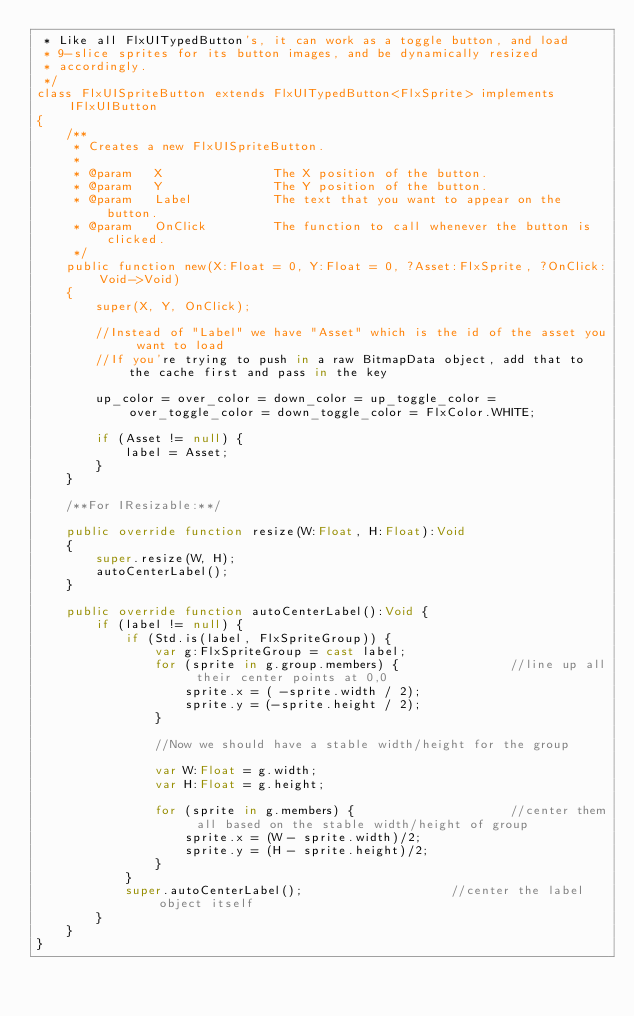Convert code to text. <code><loc_0><loc_0><loc_500><loc_500><_Haxe_> * Like all FlxUITypedButton's, it can work as a toggle button, and load
 * 9-slice sprites for its button images, and be dynamically resized 
 * accordingly.
 */
class FlxUISpriteButton extends FlxUITypedButton<FlxSprite> implements IFlxUIButton
{	
	/**
	 * Creates a new FlxUISpriteButton.
	 * 
	 * @param	X				The X position of the button.
	 * @param	Y				The Y position of the button.
	 * @param	Label			The text that you want to appear on the button.
	 * @param	OnClick			The function to call whenever the button is clicked.
	 */
	public function new(X:Float = 0, Y:Float = 0, ?Asset:FlxSprite, ?OnClick:Void->Void) 
	{
		super(X, Y, OnClick);
		
		//Instead of "Label" we have "Asset" which is the id of the asset you want to load
		//If you're trying to push in a raw BitmapData object, add that to the cache first and pass in the key
		
		up_color = over_color = down_color = up_toggle_color = over_toggle_color = down_toggle_color = FlxColor.WHITE;	
		
		if (Asset != null) {
			label = Asset;
		}
	}
	
	/**For IResizable:**/
	
	public override function resize(W:Float, H:Float):Void 
	{
		super.resize(W, H);
		autoCenterLabel();
	}
	
	public override function autoCenterLabel():Void {
		if (label != null) {
			if (Std.is(label, FlxSpriteGroup)) {
				var g:FlxSpriteGroup = cast label;
				for (sprite in g.group.members) {				//line up all their center points at 0,0
					sprite.x = ( -sprite.width / 2);
					sprite.y = (-sprite.height / 2);
				}
				
				//Now we should have a stable width/height for the group
				
				var W:Float = g.width;
				var H:Float = g.height;
				
				for (sprite in g.members) {						//center them all based on the stable width/height of group
					sprite.x = (W - sprite.width)/2;
					sprite.y = (H - sprite.height)/2;
				}
			}
			super.autoCenterLabel();					//center the label object itself
		}
	}
}</code> 